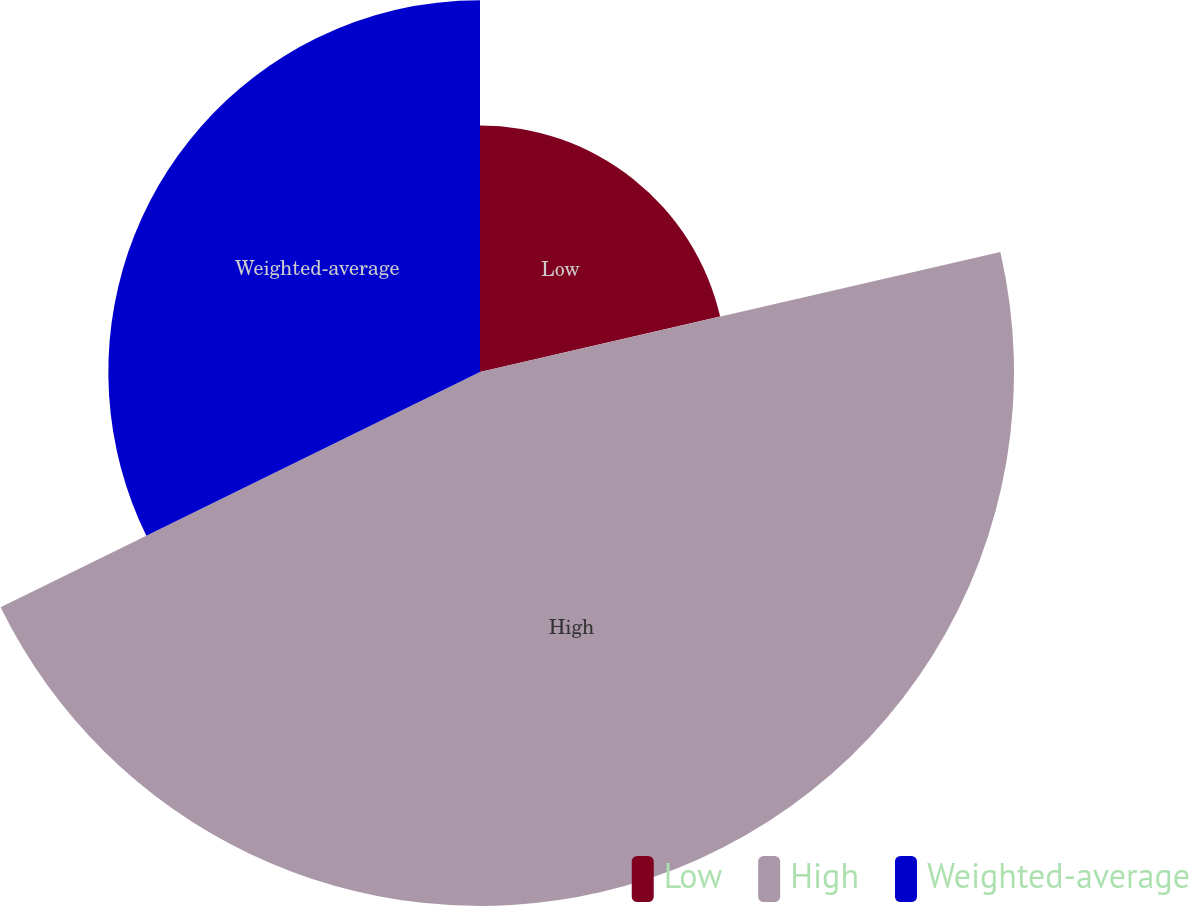Convert chart to OTSL. <chart><loc_0><loc_0><loc_500><loc_500><pie_chart><fcel>Low<fcel>High<fcel>Weighted-average<nl><fcel>21.39%<fcel>46.35%<fcel>32.26%<nl></chart> 